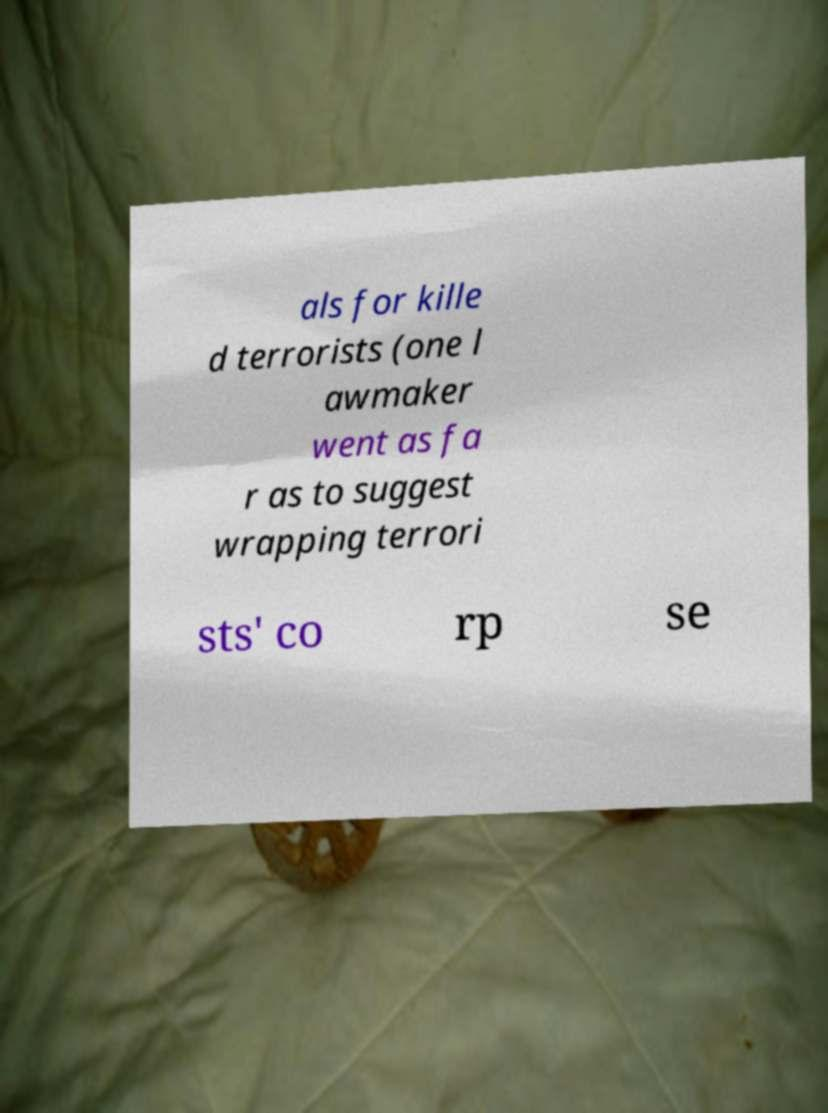I need the written content from this picture converted into text. Can you do that? als for kille d terrorists (one l awmaker went as fa r as to suggest wrapping terrori sts' co rp se 